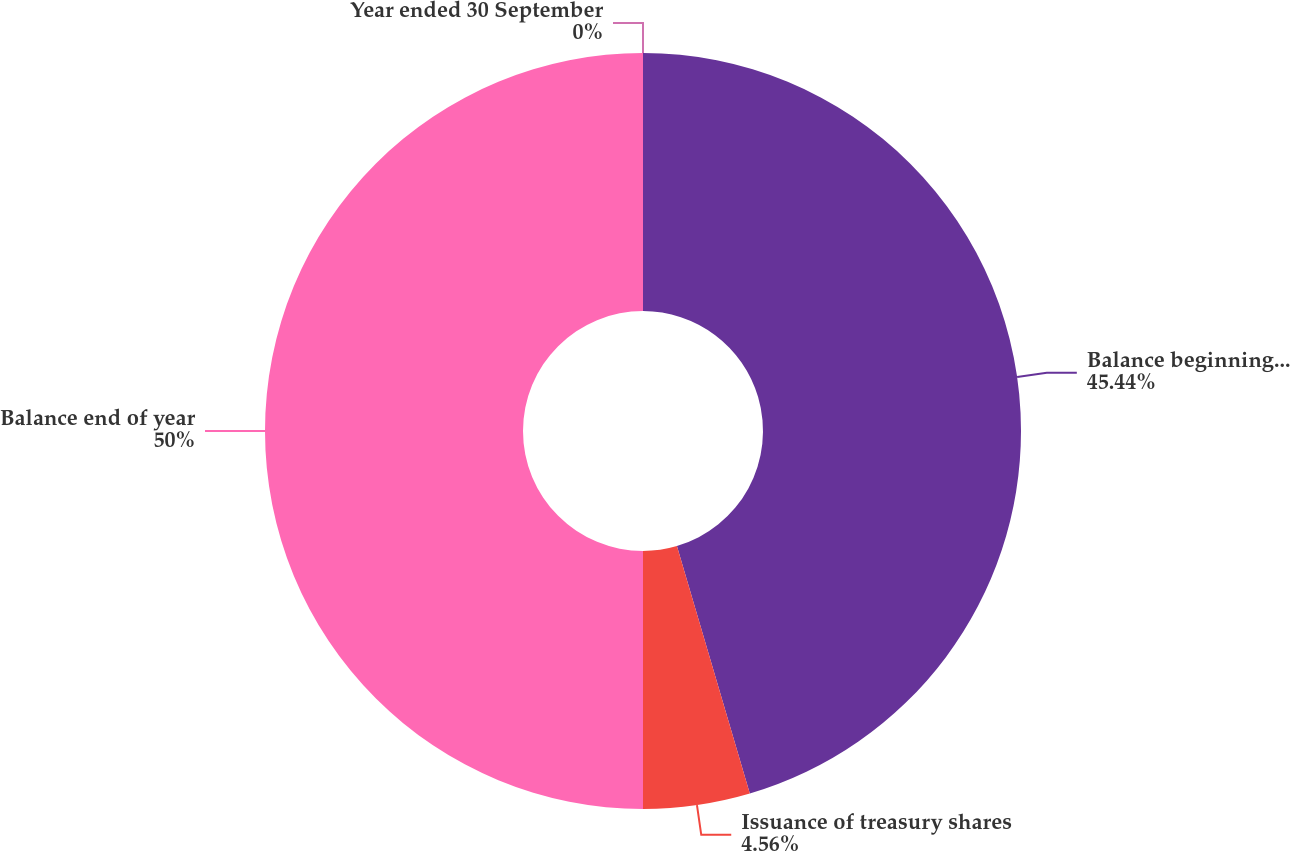Convert chart to OTSL. <chart><loc_0><loc_0><loc_500><loc_500><pie_chart><fcel>Year ended 30 September<fcel>Balance beginning of year<fcel>Issuance of treasury shares<fcel>Balance end of year<nl><fcel>0.0%<fcel>45.44%<fcel>4.56%<fcel>50.0%<nl></chart> 